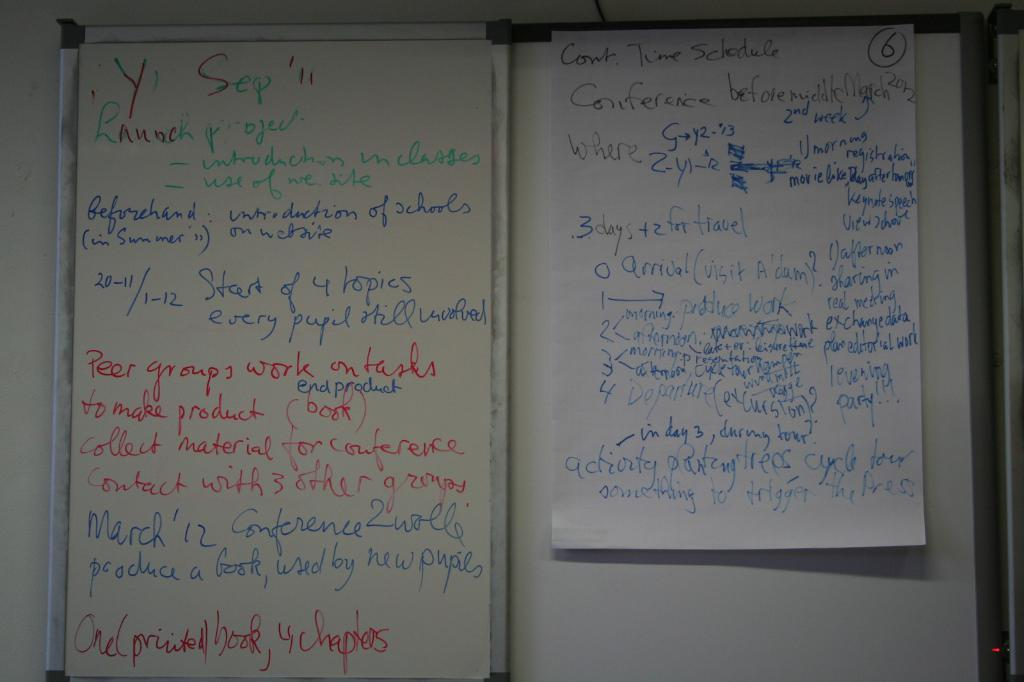<image>
Relay a brief, clear account of the picture shown. A white board has Sep '11 on it, and a white paper has Conf. Time Schedule on it. 